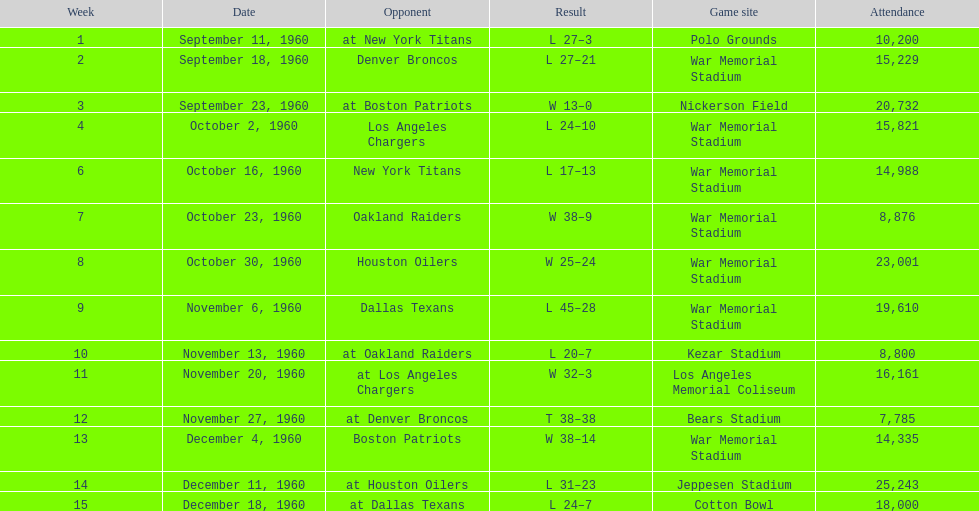What was the largest difference of points in a single game? 29. 